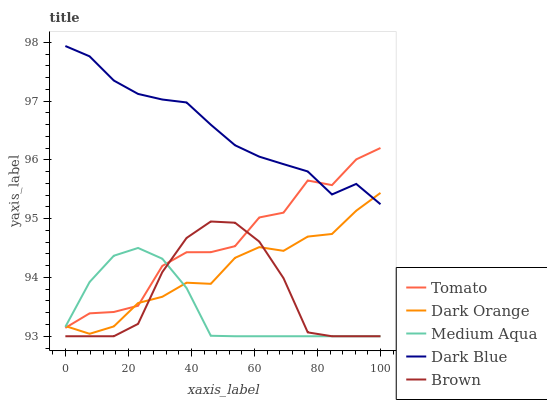Does Medium Aqua have the minimum area under the curve?
Answer yes or no. Yes. Does Dark Blue have the maximum area under the curve?
Answer yes or no. Yes. Does Dark Orange have the minimum area under the curve?
Answer yes or no. No. Does Dark Orange have the maximum area under the curve?
Answer yes or no. No. Is Medium Aqua the smoothest?
Answer yes or no. Yes. Is Tomato the roughest?
Answer yes or no. Yes. Is Dark Orange the smoothest?
Answer yes or no. No. Is Dark Orange the roughest?
Answer yes or no. No. Does Medium Aqua have the lowest value?
Answer yes or no. Yes. Does Dark Orange have the lowest value?
Answer yes or no. No. Does Dark Blue have the highest value?
Answer yes or no. Yes. Does Dark Orange have the highest value?
Answer yes or no. No. Is Medium Aqua less than Dark Blue?
Answer yes or no. Yes. Is Dark Blue greater than Medium Aqua?
Answer yes or no. Yes. Does Tomato intersect Medium Aqua?
Answer yes or no. Yes. Is Tomato less than Medium Aqua?
Answer yes or no. No. Is Tomato greater than Medium Aqua?
Answer yes or no. No. Does Medium Aqua intersect Dark Blue?
Answer yes or no. No. 